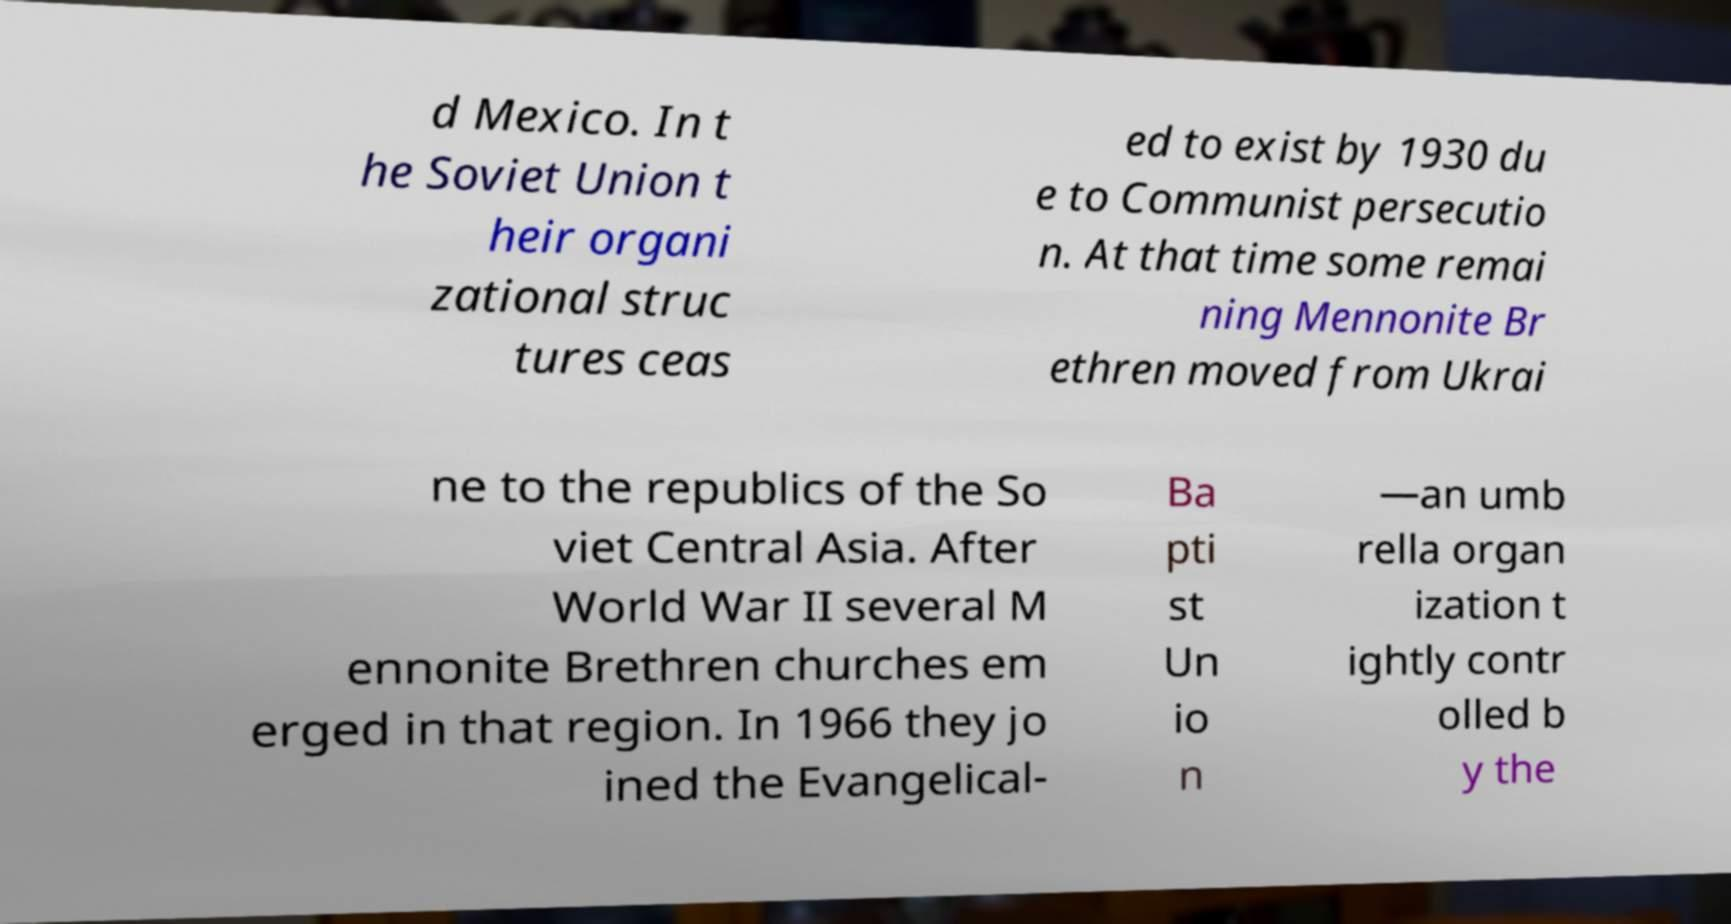Please read and relay the text visible in this image. What does it say? d Mexico. In t he Soviet Union t heir organi zational struc tures ceas ed to exist by 1930 du e to Communist persecutio n. At that time some remai ning Mennonite Br ethren moved from Ukrai ne to the republics of the So viet Central Asia. After World War II several M ennonite Brethren churches em erged in that region. In 1966 they jo ined the Evangelical- Ba pti st Un io n —an umb rella organ ization t ightly contr olled b y the 